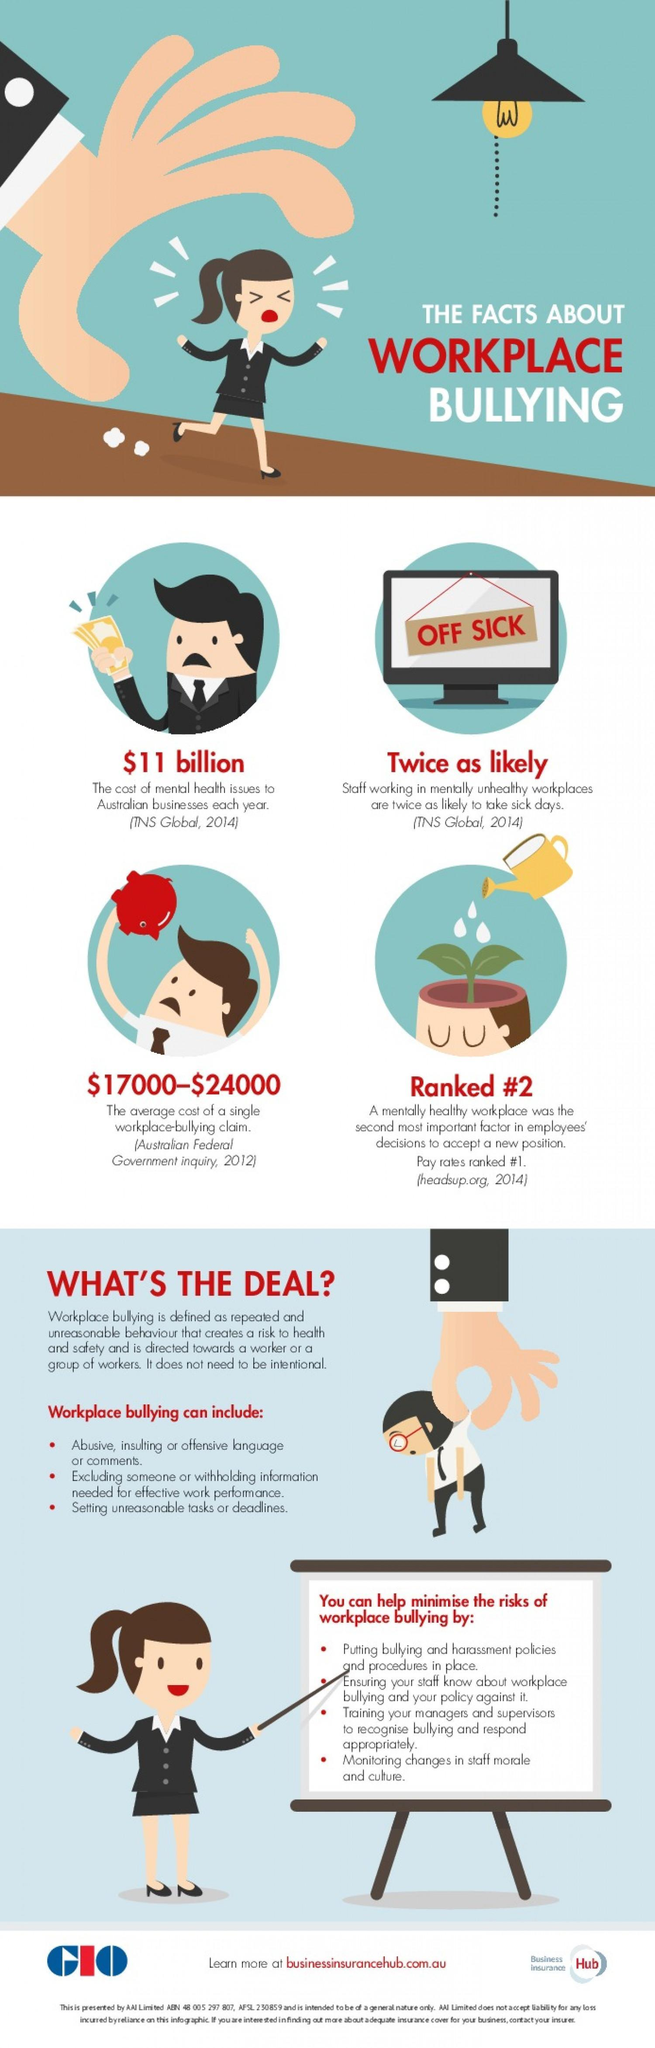Which is the most important factor in employees' decisions to accept a new position?
Answer the question with a short phrase. Pay rates 